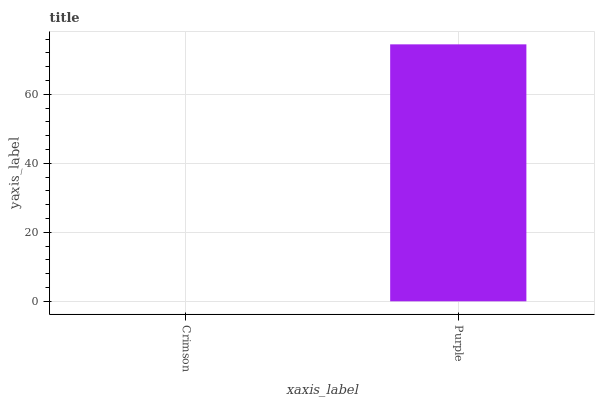Is Crimson the minimum?
Answer yes or no. Yes. Is Purple the maximum?
Answer yes or no. Yes. Is Purple the minimum?
Answer yes or no. No. Is Purple greater than Crimson?
Answer yes or no. Yes. Is Crimson less than Purple?
Answer yes or no. Yes. Is Crimson greater than Purple?
Answer yes or no. No. Is Purple less than Crimson?
Answer yes or no. No. Is Purple the high median?
Answer yes or no. Yes. Is Crimson the low median?
Answer yes or no. Yes. Is Crimson the high median?
Answer yes or no. No. Is Purple the low median?
Answer yes or no. No. 